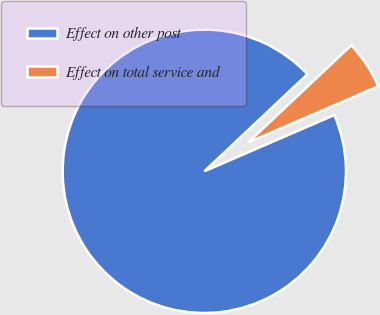Convert chart to OTSL. <chart><loc_0><loc_0><loc_500><loc_500><pie_chart><fcel>Effect on other post<fcel>Effect on total service and<nl><fcel>94.47%<fcel>5.53%<nl></chart> 